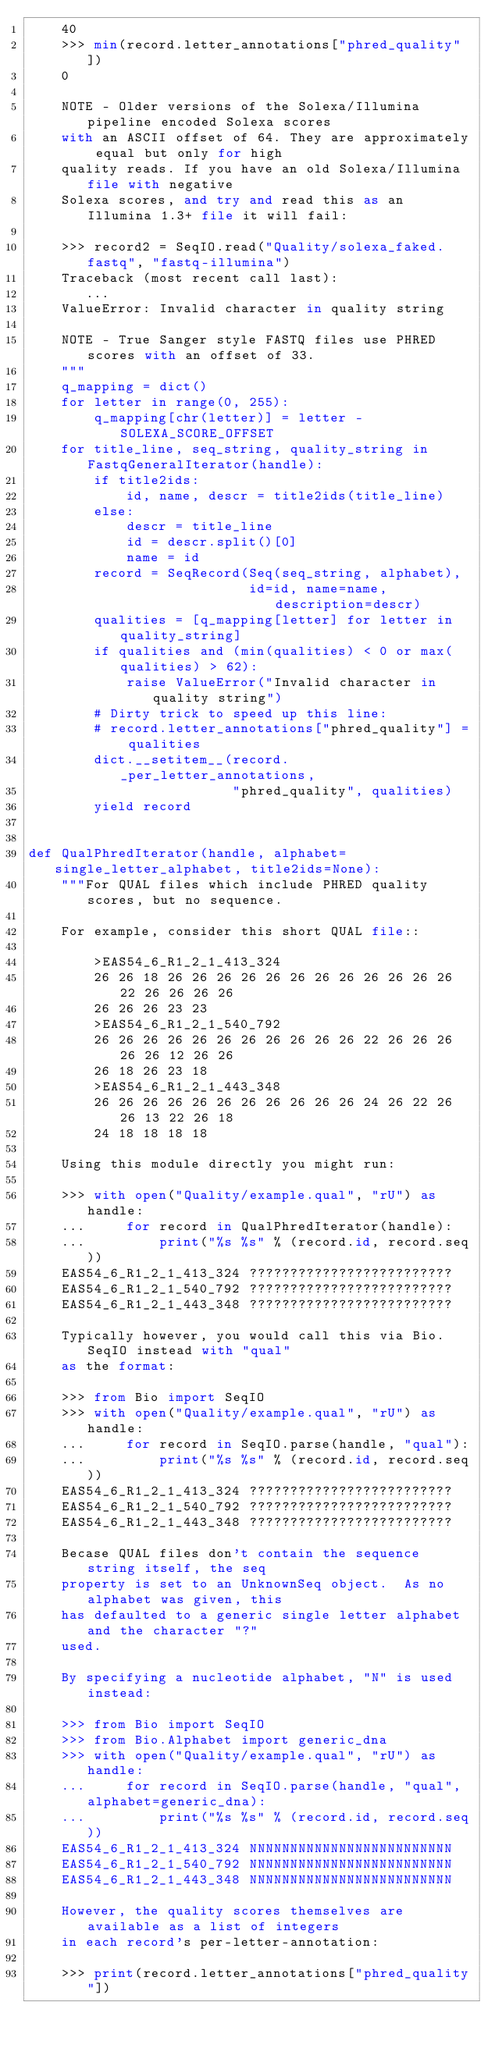<code> <loc_0><loc_0><loc_500><loc_500><_Python_>    40
    >>> min(record.letter_annotations["phred_quality"])
    0

    NOTE - Older versions of the Solexa/Illumina pipeline encoded Solexa scores
    with an ASCII offset of 64. They are approximately equal but only for high
    quality reads. If you have an old Solexa/Illumina file with negative
    Solexa scores, and try and read this as an Illumina 1.3+ file it will fail:

    >>> record2 = SeqIO.read("Quality/solexa_faked.fastq", "fastq-illumina")
    Traceback (most recent call last):
       ...
    ValueError: Invalid character in quality string

    NOTE - True Sanger style FASTQ files use PHRED scores with an offset of 33.
    """
    q_mapping = dict()
    for letter in range(0, 255):
        q_mapping[chr(letter)] = letter - SOLEXA_SCORE_OFFSET
    for title_line, seq_string, quality_string in FastqGeneralIterator(handle):
        if title2ids:
            id, name, descr = title2ids(title_line)
        else:
            descr = title_line
            id = descr.split()[0]
            name = id
        record = SeqRecord(Seq(seq_string, alphabet),
                           id=id, name=name, description=descr)
        qualities = [q_mapping[letter] for letter in quality_string]
        if qualities and (min(qualities) < 0 or max(qualities) > 62):
            raise ValueError("Invalid character in quality string")
        # Dirty trick to speed up this line:
        # record.letter_annotations["phred_quality"] = qualities
        dict.__setitem__(record._per_letter_annotations,
                         "phred_quality", qualities)
        yield record


def QualPhredIterator(handle, alphabet=single_letter_alphabet, title2ids=None):
    """For QUAL files which include PHRED quality scores, but no sequence.

    For example, consider this short QUAL file::

        >EAS54_6_R1_2_1_413_324
        26 26 18 26 26 26 26 26 26 26 26 26 26 26 26 22 26 26 26 26
        26 26 26 23 23
        >EAS54_6_R1_2_1_540_792
        26 26 26 26 26 26 26 26 26 26 26 22 26 26 26 26 26 12 26 26
        26 18 26 23 18
        >EAS54_6_R1_2_1_443_348
        26 26 26 26 26 26 26 26 26 26 26 24 26 22 26 26 13 22 26 18
        24 18 18 18 18

    Using this module directly you might run:

    >>> with open("Quality/example.qual", "rU") as handle:
    ...     for record in QualPhredIterator(handle):
    ...         print("%s %s" % (record.id, record.seq))
    EAS54_6_R1_2_1_413_324 ?????????????????????????
    EAS54_6_R1_2_1_540_792 ?????????????????????????
    EAS54_6_R1_2_1_443_348 ?????????????????????????

    Typically however, you would call this via Bio.SeqIO instead with "qual"
    as the format:

    >>> from Bio import SeqIO
    >>> with open("Quality/example.qual", "rU") as handle:
    ...     for record in SeqIO.parse(handle, "qual"):
    ...         print("%s %s" % (record.id, record.seq))
    EAS54_6_R1_2_1_413_324 ?????????????????????????
    EAS54_6_R1_2_1_540_792 ?????????????????????????
    EAS54_6_R1_2_1_443_348 ?????????????????????????

    Becase QUAL files don't contain the sequence string itself, the seq
    property is set to an UnknownSeq object.  As no alphabet was given, this
    has defaulted to a generic single letter alphabet and the character "?"
    used.

    By specifying a nucleotide alphabet, "N" is used instead:

    >>> from Bio import SeqIO
    >>> from Bio.Alphabet import generic_dna
    >>> with open("Quality/example.qual", "rU") as handle:
    ...     for record in SeqIO.parse(handle, "qual", alphabet=generic_dna):
    ...         print("%s %s" % (record.id, record.seq))
    EAS54_6_R1_2_1_413_324 NNNNNNNNNNNNNNNNNNNNNNNNN
    EAS54_6_R1_2_1_540_792 NNNNNNNNNNNNNNNNNNNNNNNNN
    EAS54_6_R1_2_1_443_348 NNNNNNNNNNNNNNNNNNNNNNNNN

    However, the quality scores themselves are available as a list of integers
    in each record's per-letter-annotation:

    >>> print(record.letter_annotations["phred_quality"])</code> 